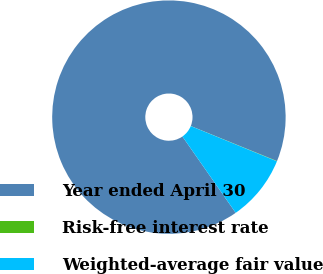<chart> <loc_0><loc_0><loc_500><loc_500><pie_chart><fcel>Year ended April 30<fcel>Risk-free interest rate<fcel>Weighted-average fair value<nl><fcel>90.85%<fcel>0.04%<fcel>9.12%<nl></chart> 